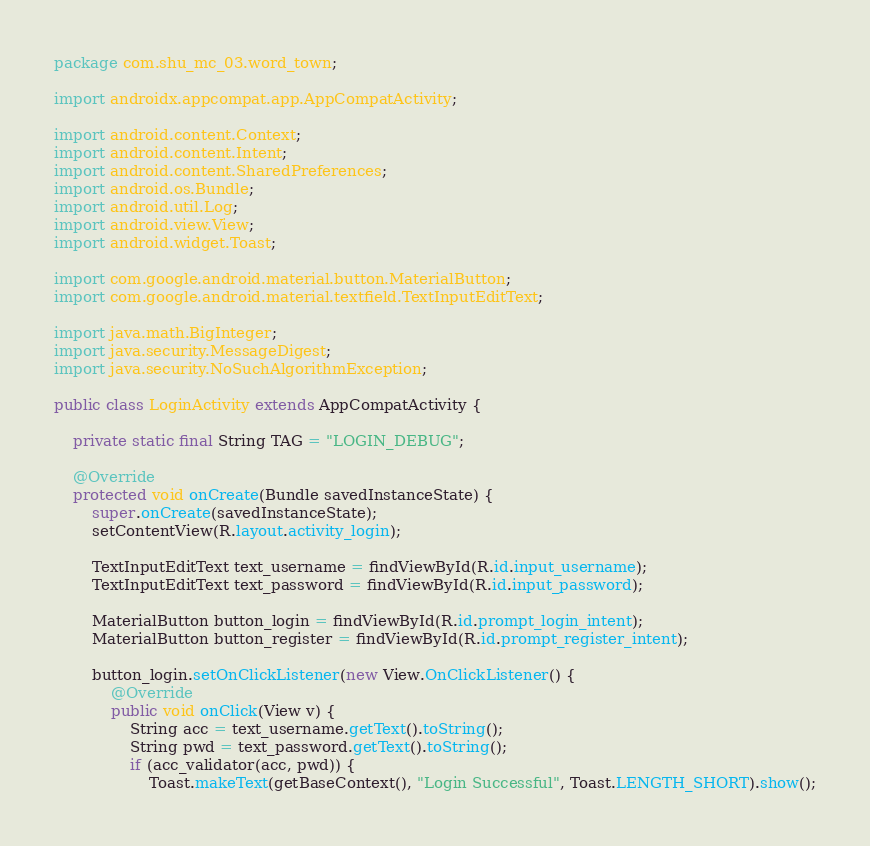Convert code to text. <code><loc_0><loc_0><loc_500><loc_500><_Java_>package com.shu_mc_03.word_town;

import androidx.appcompat.app.AppCompatActivity;

import android.content.Context;
import android.content.Intent;
import android.content.SharedPreferences;
import android.os.Bundle;
import android.util.Log;
import android.view.View;
import android.widget.Toast;

import com.google.android.material.button.MaterialButton;
import com.google.android.material.textfield.TextInputEditText;

import java.math.BigInteger;
import java.security.MessageDigest;
import java.security.NoSuchAlgorithmException;

public class LoginActivity extends AppCompatActivity {

    private static final String TAG = "LOGIN_DEBUG";

    @Override
    protected void onCreate(Bundle savedInstanceState) {
        super.onCreate(savedInstanceState);
        setContentView(R.layout.activity_login);

        TextInputEditText text_username = findViewById(R.id.input_username);
        TextInputEditText text_password = findViewById(R.id.input_password);

        MaterialButton button_login = findViewById(R.id.prompt_login_intent);
        MaterialButton button_register = findViewById(R.id.prompt_register_intent);

        button_login.setOnClickListener(new View.OnClickListener() {
            @Override
            public void onClick(View v) {
                String acc = text_username.getText().toString();
                String pwd = text_password.getText().toString();
                if (acc_validator(acc, pwd)) {
                    Toast.makeText(getBaseContext(), "Login Successful", Toast.LENGTH_SHORT).show();</code> 